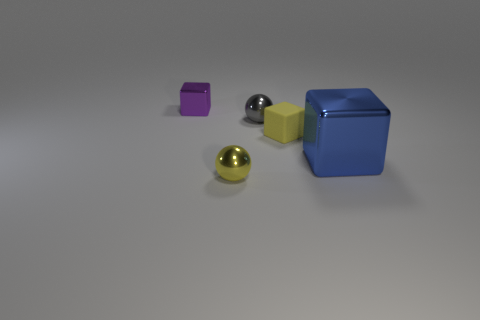Add 3 tiny rubber blocks. How many objects exist? 8 Subtract all cubes. How many objects are left? 2 Subtract all large brown matte cylinders. Subtract all small matte things. How many objects are left? 4 Add 4 small objects. How many small objects are left? 8 Add 1 yellow shiny objects. How many yellow shiny objects exist? 2 Subtract 0 gray blocks. How many objects are left? 5 